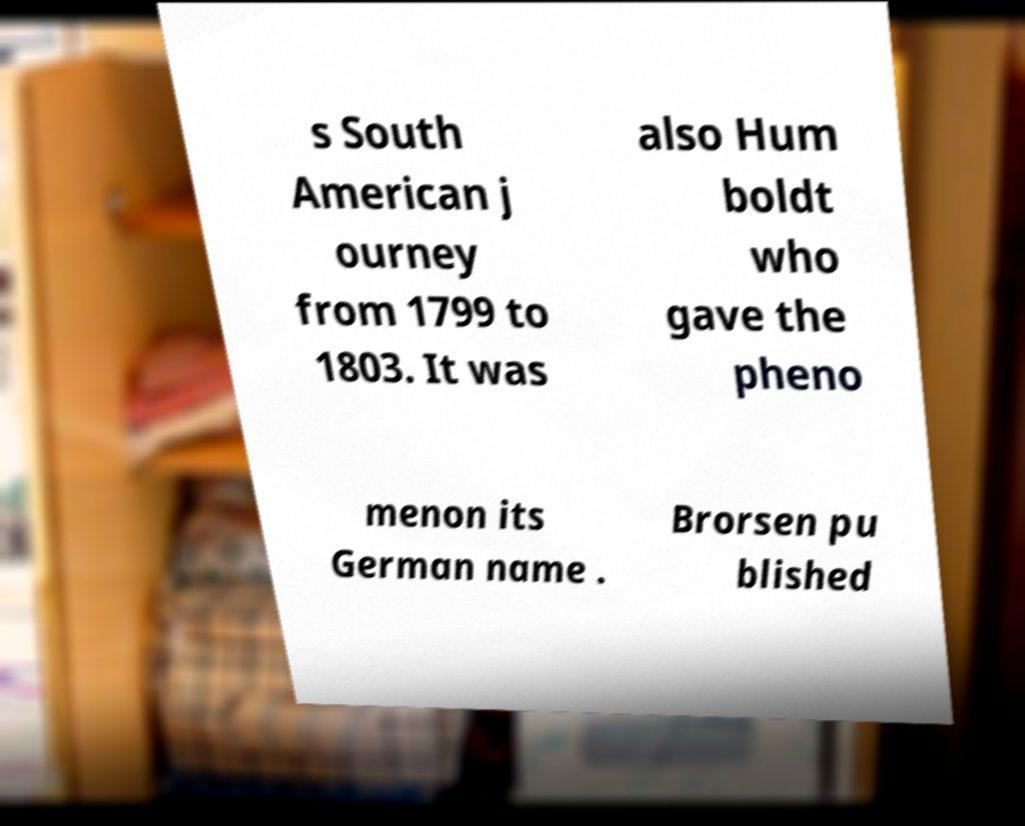Could you extract and type out the text from this image? s South American j ourney from 1799 to 1803. It was also Hum boldt who gave the pheno menon its German name . Brorsen pu blished 